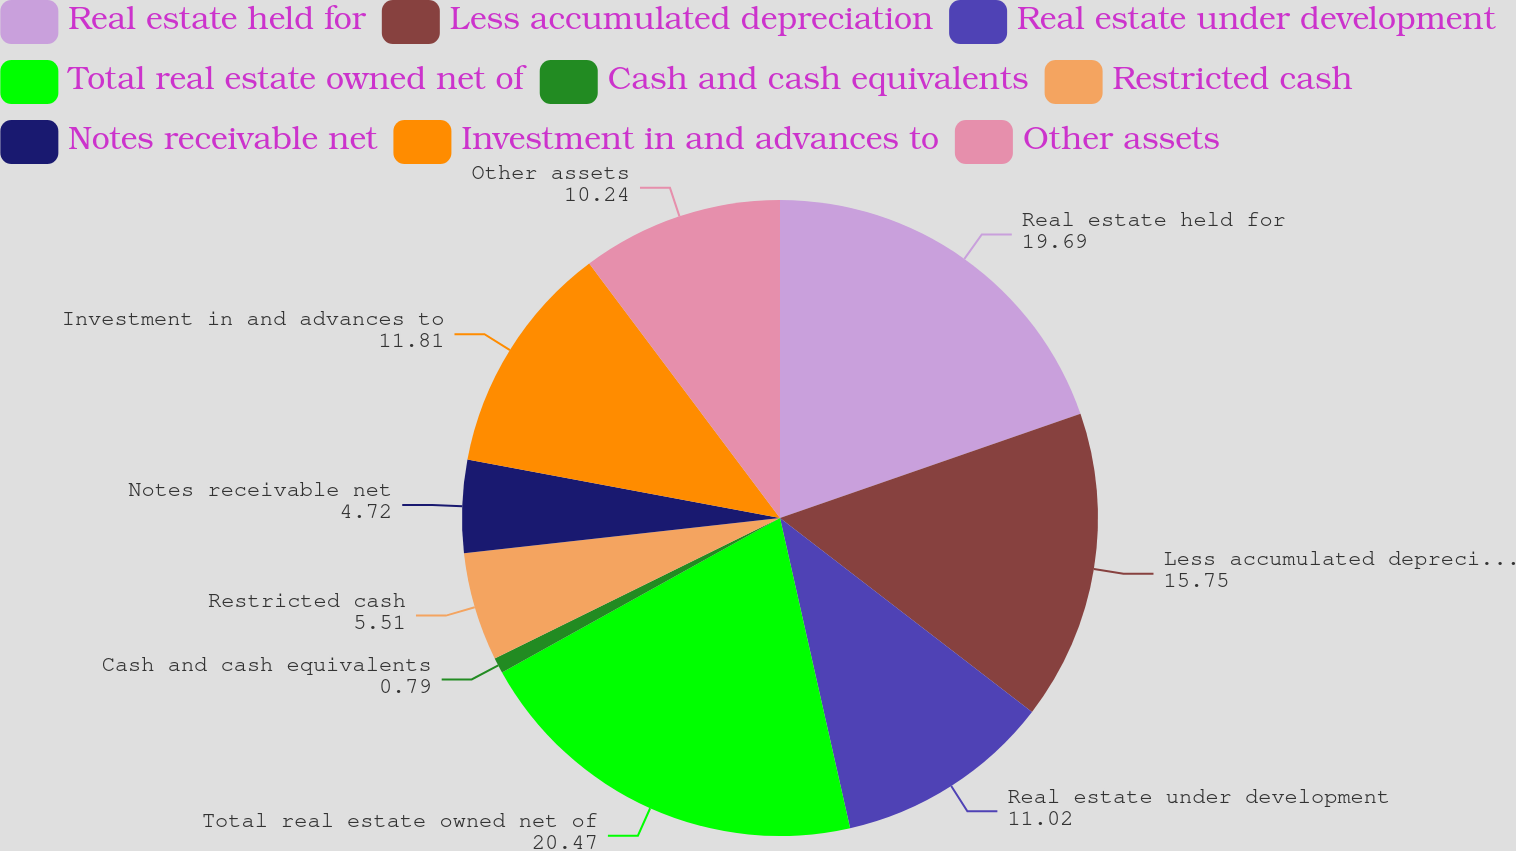Convert chart. <chart><loc_0><loc_0><loc_500><loc_500><pie_chart><fcel>Real estate held for<fcel>Less accumulated depreciation<fcel>Real estate under development<fcel>Total real estate owned net of<fcel>Cash and cash equivalents<fcel>Restricted cash<fcel>Notes receivable net<fcel>Investment in and advances to<fcel>Other assets<nl><fcel>19.69%<fcel>15.75%<fcel>11.02%<fcel>20.47%<fcel>0.79%<fcel>5.51%<fcel>4.72%<fcel>11.81%<fcel>10.24%<nl></chart> 